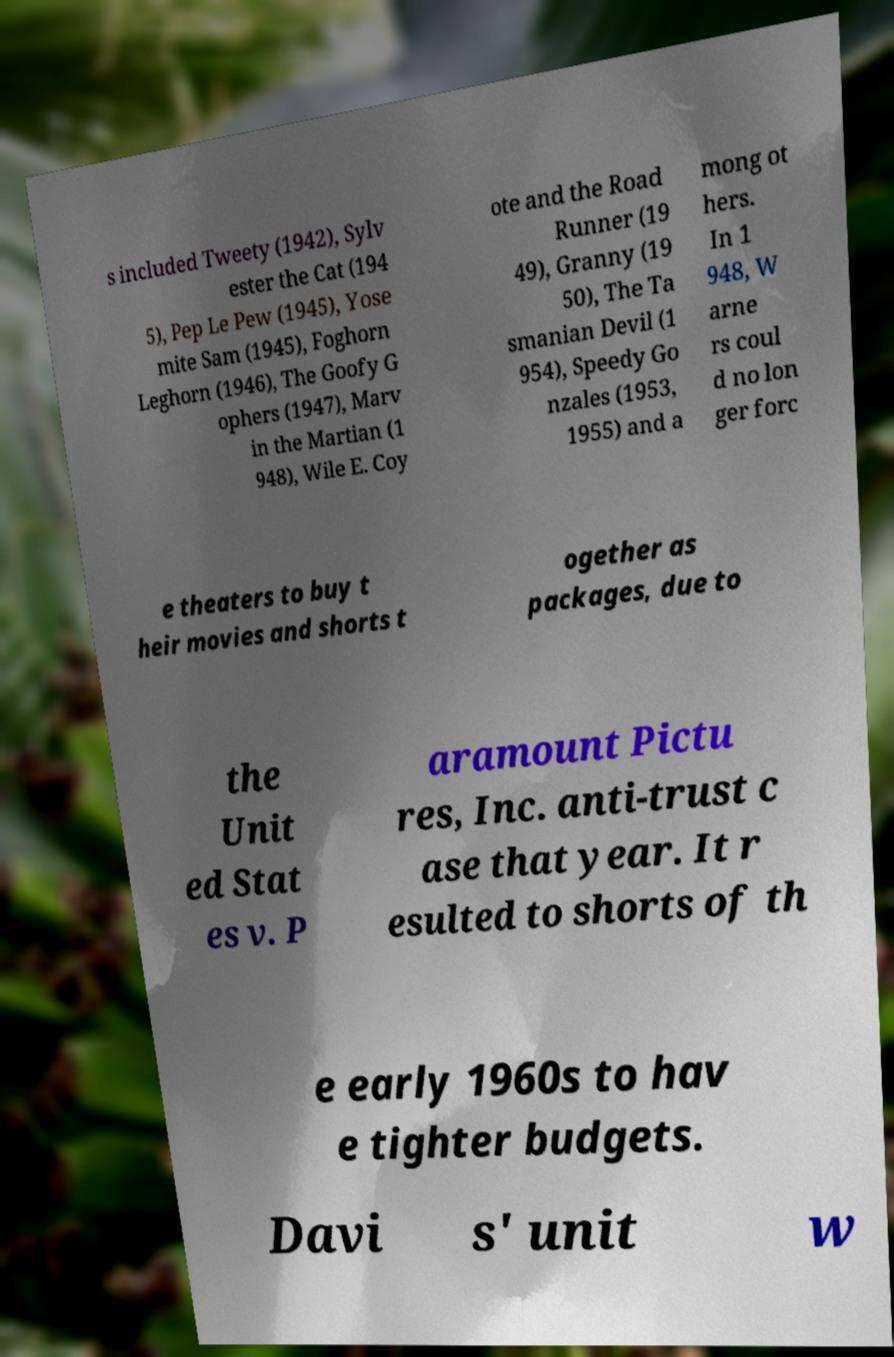What messages or text are displayed in this image? I need them in a readable, typed format. s included Tweety (1942), Sylv ester the Cat (194 5), Pep Le Pew (1945), Yose mite Sam (1945), Foghorn Leghorn (1946), The Goofy G ophers (1947), Marv in the Martian (1 948), Wile E. Coy ote and the Road Runner (19 49), Granny (19 50), The Ta smanian Devil (1 954), Speedy Go nzales (1953, 1955) and a mong ot hers. In 1 948, W arne rs coul d no lon ger forc e theaters to buy t heir movies and shorts t ogether as packages, due to the Unit ed Stat es v. P aramount Pictu res, Inc. anti-trust c ase that year. It r esulted to shorts of th e early 1960s to hav e tighter budgets. Davi s' unit w 